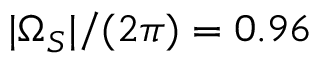Convert formula to latex. <formula><loc_0><loc_0><loc_500><loc_500>| \Omega _ { S } | / ( 2 \pi ) = 0 . 9 6</formula> 